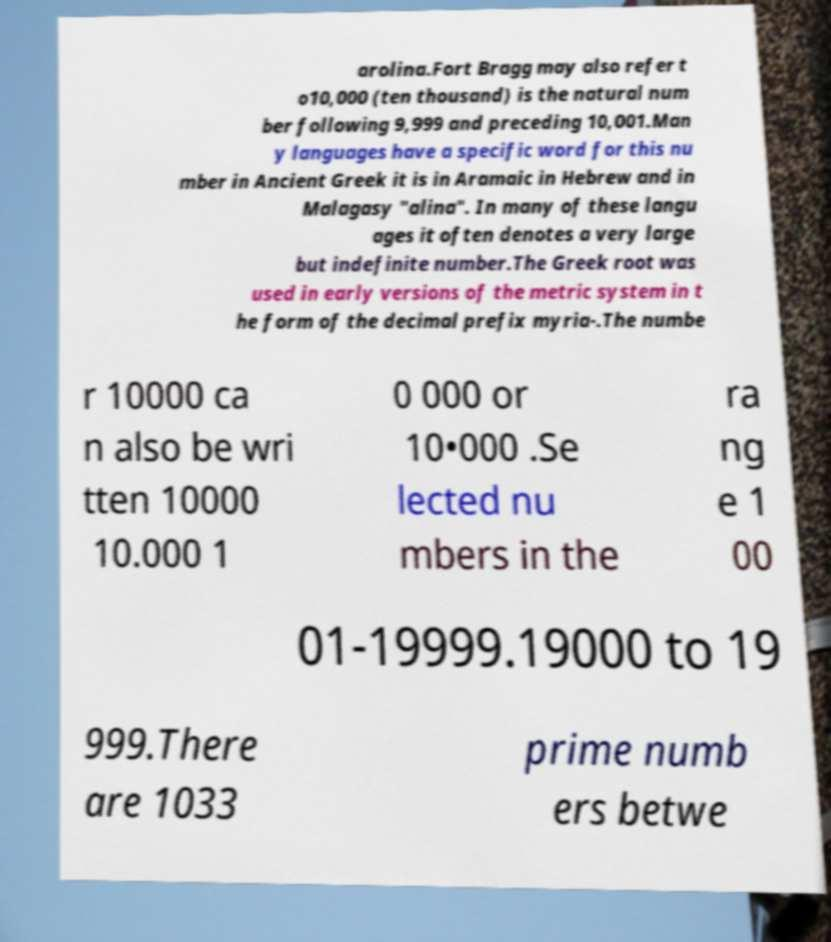For documentation purposes, I need the text within this image transcribed. Could you provide that? arolina.Fort Bragg may also refer t o10,000 (ten thousand) is the natural num ber following 9,999 and preceding 10,001.Man y languages have a specific word for this nu mber in Ancient Greek it is in Aramaic in Hebrew and in Malagasy "alina". In many of these langu ages it often denotes a very large but indefinite number.The Greek root was used in early versions of the metric system in t he form of the decimal prefix myria-.The numbe r 10000 ca n also be wri tten 10000 10.000 1 0 000 or 10•000 .Se lected nu mbers in the ra ng e 1 00 01-19999.19000 to 19 999.There are 1033 prime numb ers betwe 